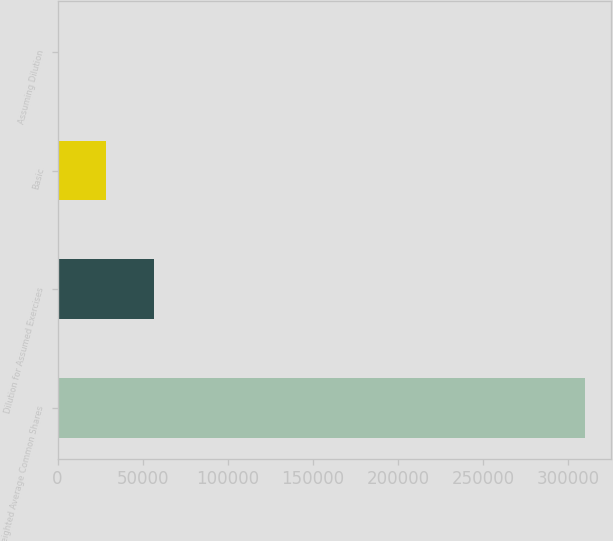<chart> <loc_0><loc_0><loc_500><loc_500><bar_chart><fcel>Weighted Average Common Shares<fcel>Dilution for Assumed Exercises<fcel>Basic<fcel>Assuming Dilution<nl><fcel>309531<fcel>56353.9<fcel>28178.5<fcel>3.17<nl></chart> 